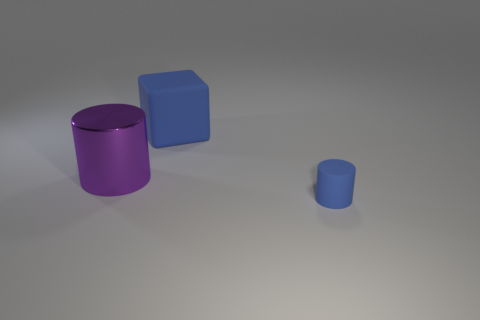Add 1 blue rubber cubes. How many objects exist? 4 Subtract all blocks. How many objects are left? 2 Subtract all small blue metal balls. Subtract all blue blocks. How many objects are left? 2 Add 2 small cylinders. How many small cylinders are left? 3 Add 1 big metallic objects. How many big metallic objects exist? 2 Subtract 0 green balls. How many objects are left? 3 